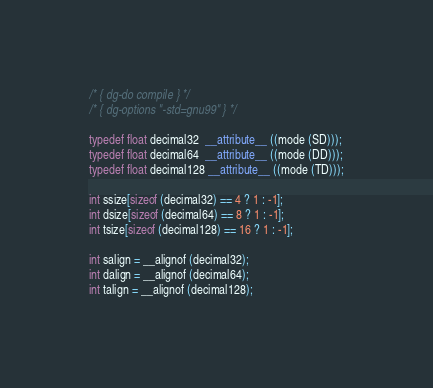Convert code to text. <code><loc_0><loc_0><loc_500><loc_500><_C_>/* { dg-do compile } */
/* { dg-options "-std=gnu99" } */

typedef float decimal32  __attribute__ ((mode (SD)));
typedef float decimal64  __attribute__ ((mode (DD)));
typedef float decimal128 __attribute__ ((mode (TD)));

int ssize[sizeof (decimal32) == 4 ? 1 : -1];
int dsize[sizeof (decimal64) == 8 ? 1 : -1];
int tsize[sizeof (decimal128) == 16 ? 1 : -1];

int salign = __alignof (decimal32);
int dalign = __alignof (decimal64);
int talign = __alignof (decimal128);

</code> 